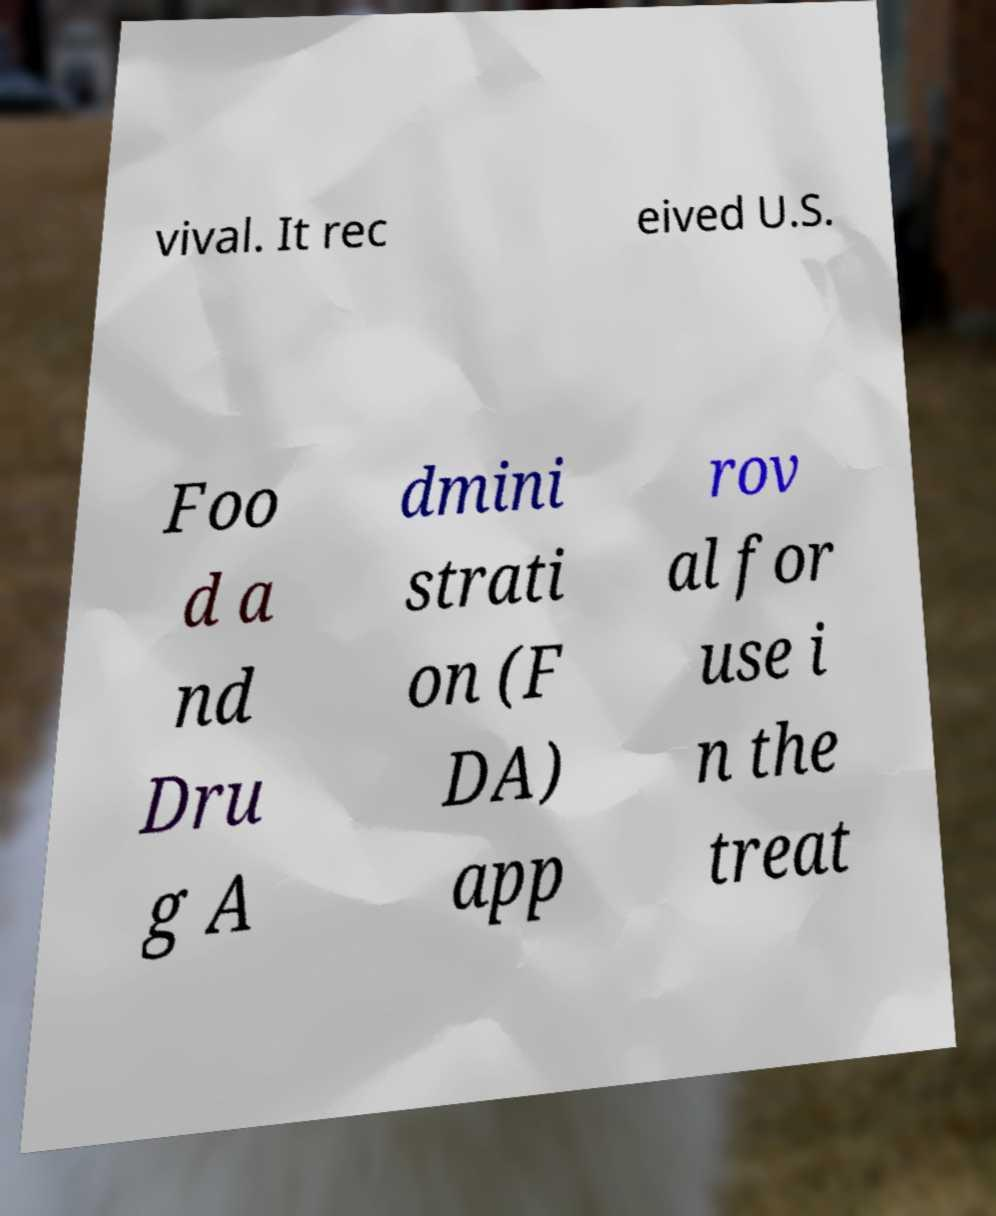Can you read and provide the text displayed in the image?This photo seems to have some interesting text. Can you extract and type it out for me? vival. It rec eived U.S. Foo d a nd Dru g A dmini strati on (F DA) app rov al for use i n the treat 